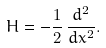<formula> <loc_0><loc_0><loc_500><loc_500>H = - \frac { 1 } { 2 } \, \frac { d ^ { 2 } } { d x ^ { 2 } } .</formula> 